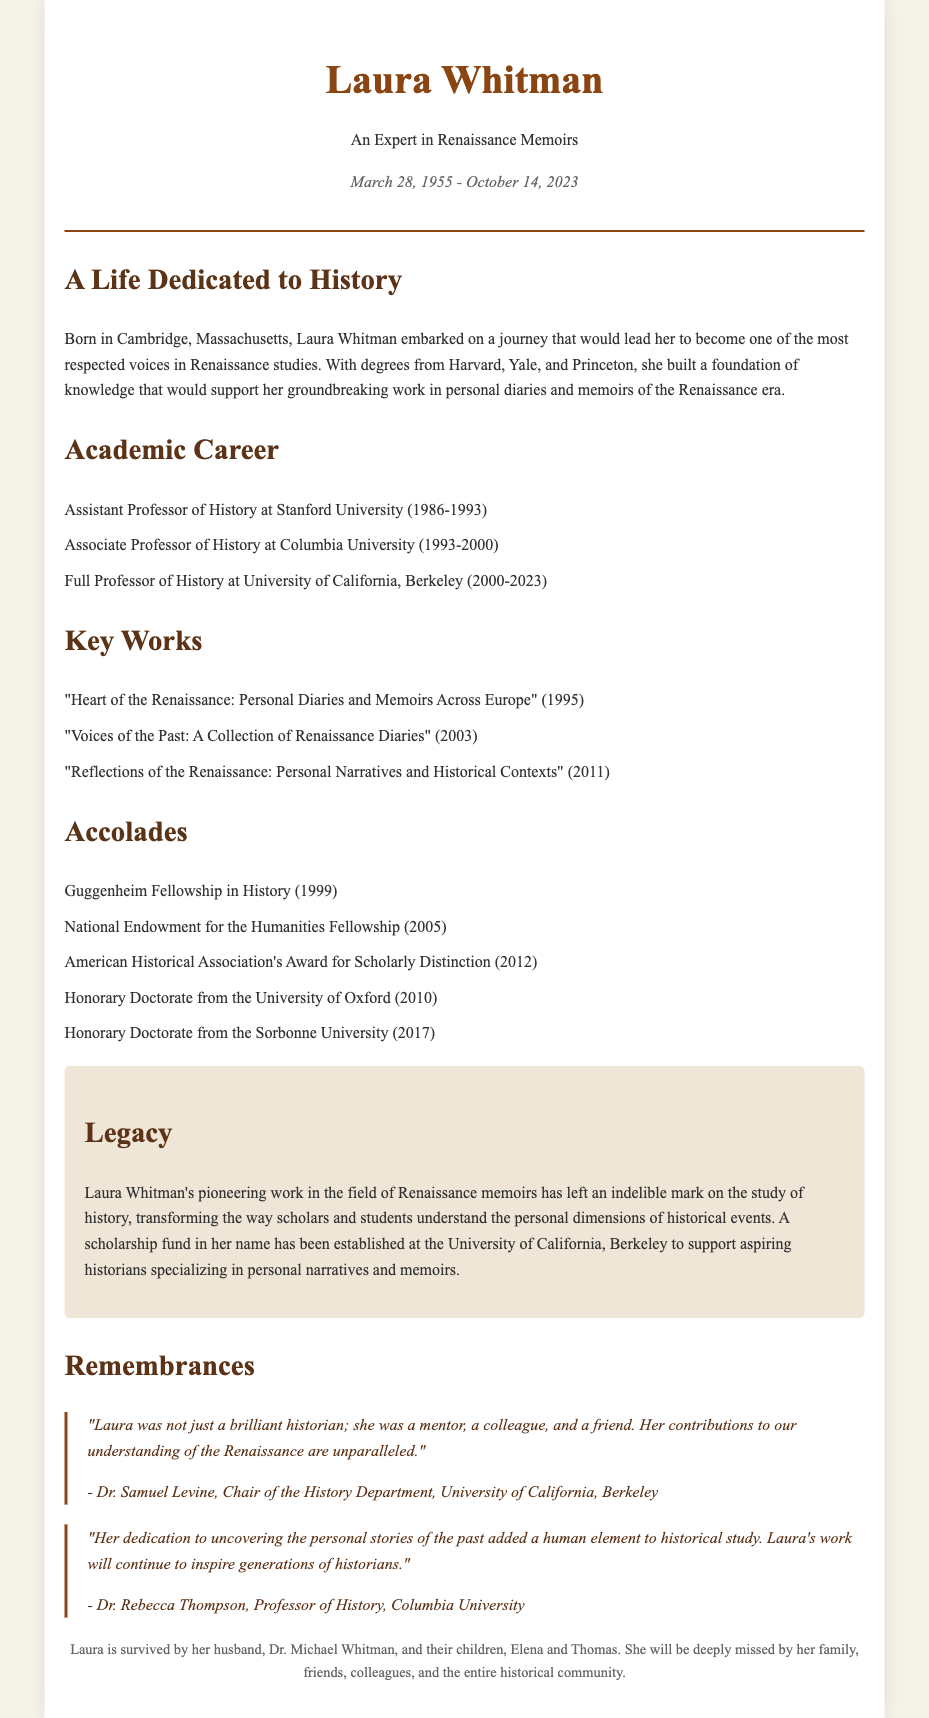what is Laura Whitman's date of birth? Laura Whitman's date of birth is mentioned in the document as March 28, 1955.
Answer: March 28, 1955 where did Laura Whitman earn her degrees? The document states that she earned degrees from Harvard, Yale, and Princeton.
Answer: Harvard, Yale, and Princeton how many key works are listed in the document? The document lists three key works authored by Laura Whitman.
Answer: three which fellowship did Laura Whitman receive in 1999? The document states that she received the Guggenheim Fellowship in History in 1999.
Answer: Guggenheim Fellowship in History who described Laura as a mentor, colleague, and friend? The document includes a quote from Dr. Samuel Levine, who described Laura in this manner.
Answer: Dr. Samuel Levine what was the purpose of the scholarship fund established in Laura Whitman's name? The scholarship fund established in her name aims to support aspiring historians specializing in personal narratives and memoirs.
Answer: Support aspiring historians how many honorary doctorates did Laura Whitman receive? The document mentions that Laura received two honorary doctorates.
Answer: two what university did Laura Whitman work at as a Full Professor of History? According to the document, she worked as a Full Professor of History at the University of California, Berkeley.
Answer: University of California, Berkeley what is emphasized about Laura Whitman's contributions to history? The document emphasizes that her work transformed the understanding of personal dimensions of historical events.
Answer: Transform understanding of personal dimensions of history 